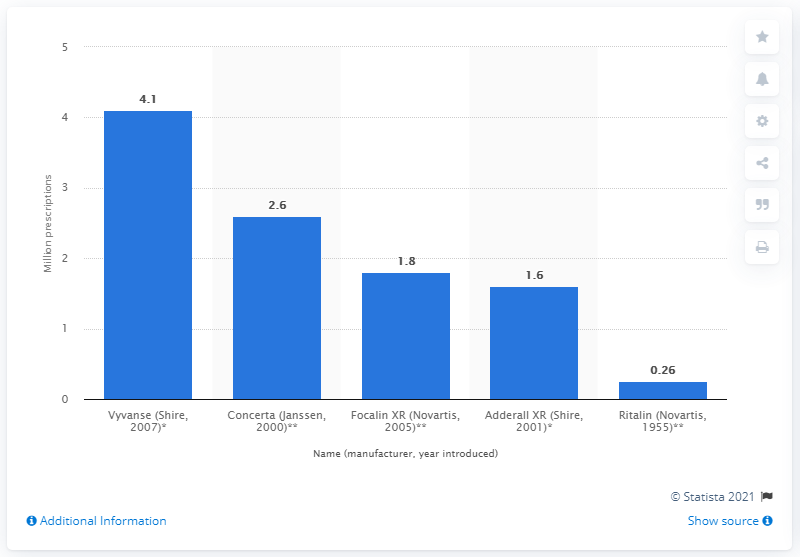Indicate a few pertinent items in this graphic. Between 10 and 19 years old, children with ADHD were prescribed Adderall XR an average of 1.6 times. 